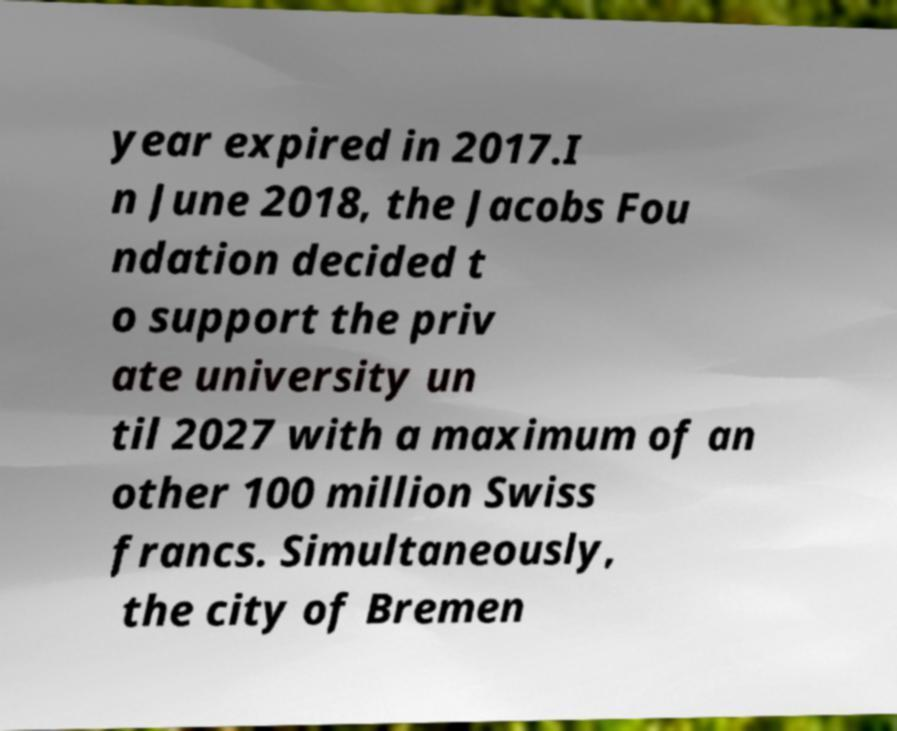Could you assist in decoding the text presented in this image and type it out clearly? year expired in 2017.I n June 2018, the Jacobs Fou ndation decided t o support the priv ate university un til 2027 with a maximum of an other 100 million Swiss francs. Simultaneously, the city of Bremen 